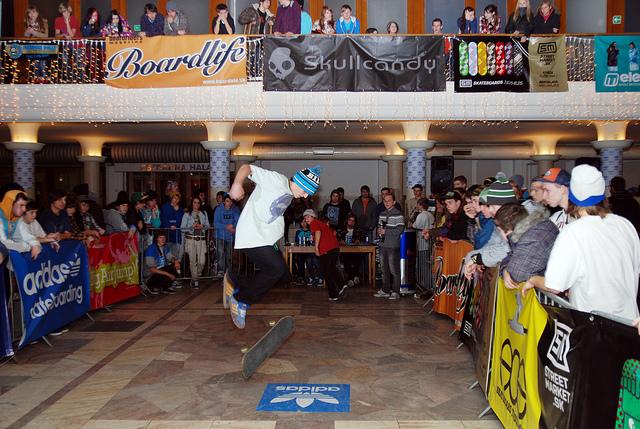What is the man trying to jump on?
Answer briefly. Skateboard. What logo is painted to the floor?
Concise answer only. Adidas. Is there a skateboard?
Short answer required. Yes. 